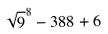Convert formula to latex. <formula><loc_0><loc_0><loc_500><loc_500>\sqrt { 9 } ^ { 8 } - 3 8 8 + 6</formula> 